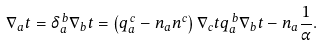<formula> <loc_0><loc_0><loc_500><loc_500>\nabla _ { a } t = \delta _ { a } ^ { \, b } \nabla _ { b } t = \left ( q _ { a } ^ { \, c } - n _ { a } n ^ { c } \right ) \nabla _ { c } t q _ { a } ^ { \, b } \nabla _ { b } t - n _ { a } \frac { 1 } { \alpha } .</formula> 